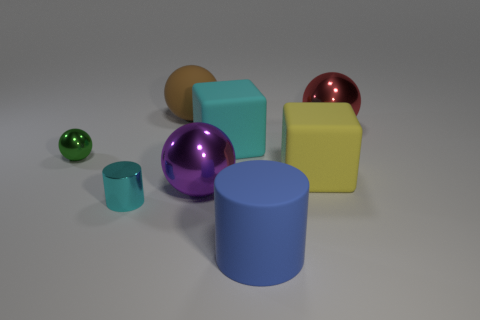Add 1 big blue matte cylinders. How many objects exist? 9 Subtract all blocks. How many objects are left? 6 Add 7 big yellow objects. How many big yellow objects are left? 8 Add 7 large cyan things. How many large cyan things exist? 8 Subtract 0 red cylinders. How many objects are left? 8 Subtract all small yellow things. Subtract all large brown things. How many objects are left? 7 